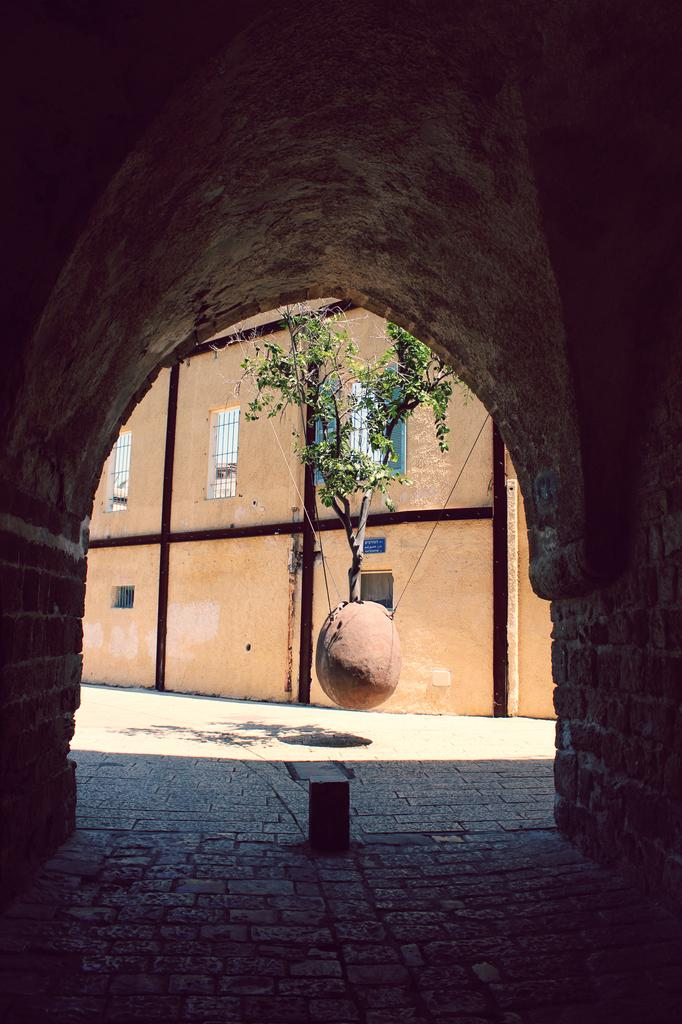What type of plant can be seen in the image? There is a tree with branches and leaves in the image. What object is tied with ropes in the image? There is a stone tied with ropes in the image. What type of structure is present in the image? There is a tunnel in the image. What type of building can be seen in the image? There is a building with windows in the image. Where is the suit located in the image? There is no suit present in the image. What type of coast can be seen in the image? There is no coast visible in the image. 